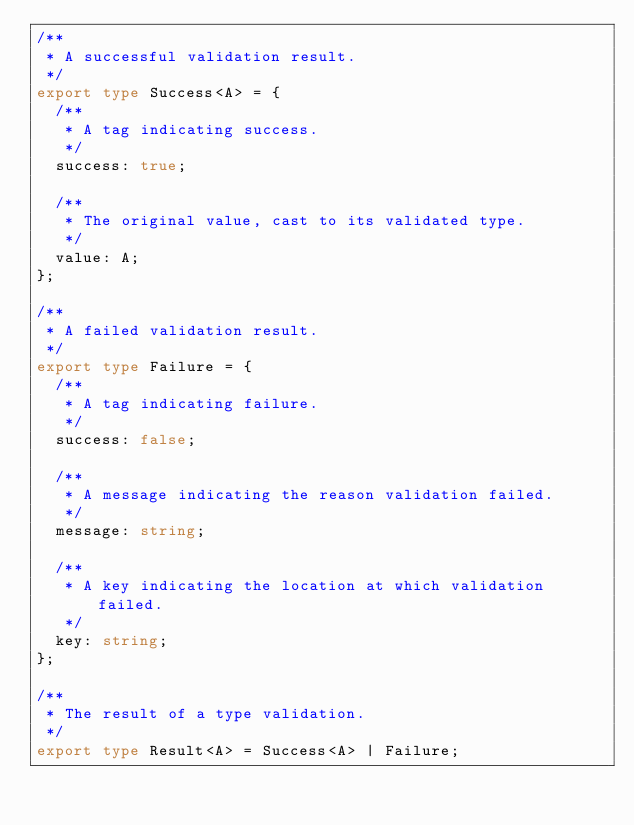Convert code to text. <code><loc_0><loc_0><loc_500><loc_500><_TypeScript_>/**
 * A successful validation result.
 */
export type Success<A> = {
  /**
   * A tag indicating success.
   */
  success: true;

  /**
   * The original value, cast to its validated type.
   */
  value: A;
};

/**
 * A failed validation result.
 */
export type Failure = {
  /**
   * A tag indicating failure.
   */
  success: false;

  /**
   * A message indicating the reason validation failed.
   */
  message: string;

  /**
   * A key indicating the location at which validation failed.
   */
  key: string;
};

/**
 * The result of a type validation.
 */
export type Result<A> = Success<A> | Failure;
</code> 